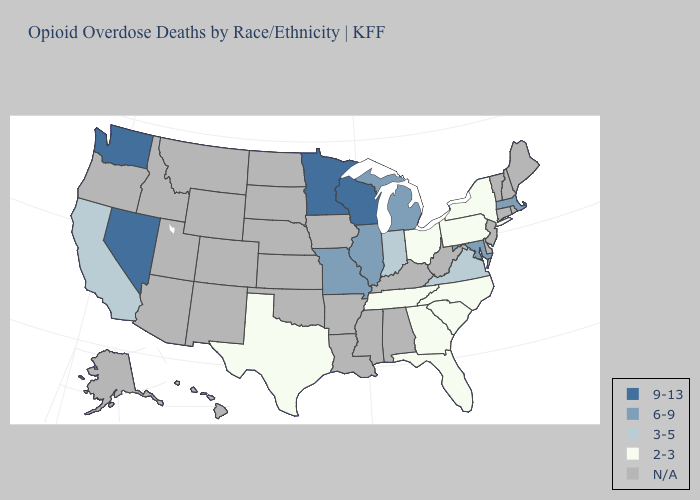Among the states that border South Dakota , which have the lowest value?
Write a very short answer. Minnesota. Name the states that have a value in the range 9-13?
Short answer required. Minnesota, Nevada, Washington, Wisconsin. What is the value of Arkansas?
Keep it brief. N/A. What is the lowest value in the South?
Give a very brief answer. 2-3. Among the states that border Michigan , which have the highest value?
Short answer required. Wisconsin. Name the states that have a value in the range 6-9?
Short answer required. Illinois, Maryland, Massachusetts, Michigan, Missouri. Does Maryland have the highest value in the South?
Answer briefly. Yes. What is the value of Kentucky?
Keep it brief. N/A. Name the states that have a value in the range 3-5?
Keep it brief. California, Indiana, Virginia. Name the states that have a value in the range 9-13?
Be succinct. Minnesota, Nevada, Washington, Wisconsin. What is the value of Arizona?
Be succinct. N/A. What is the value of Oklahoma?
Concise answer only. N/A. Which states have the highest value in the USA?
Quick response, please. Minnesota, Nevada, Washington, Wisconsin. 